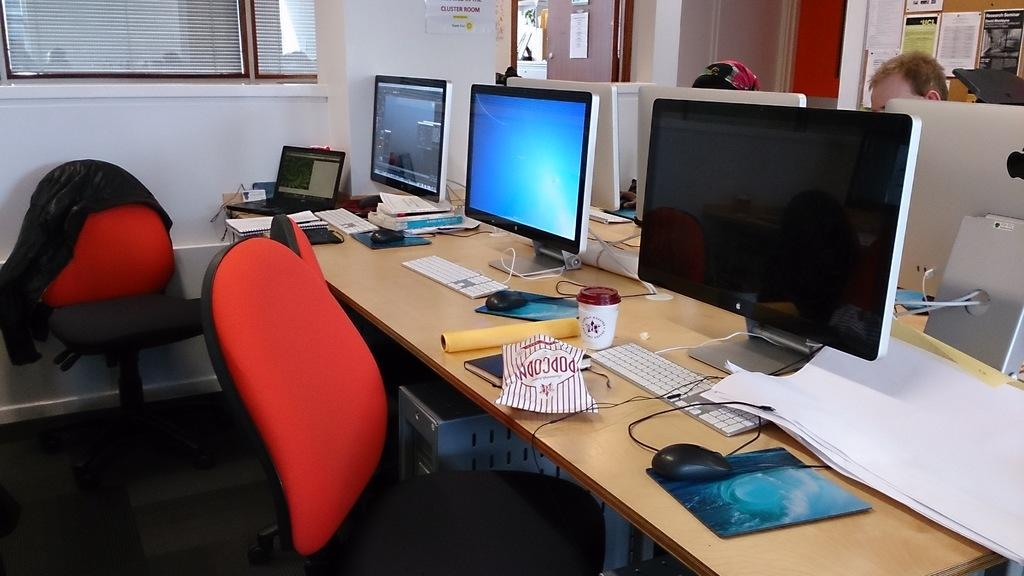<image>
Present a compact description of the photo's key features. A bag of popcorn lays on the table in front of a computer. 